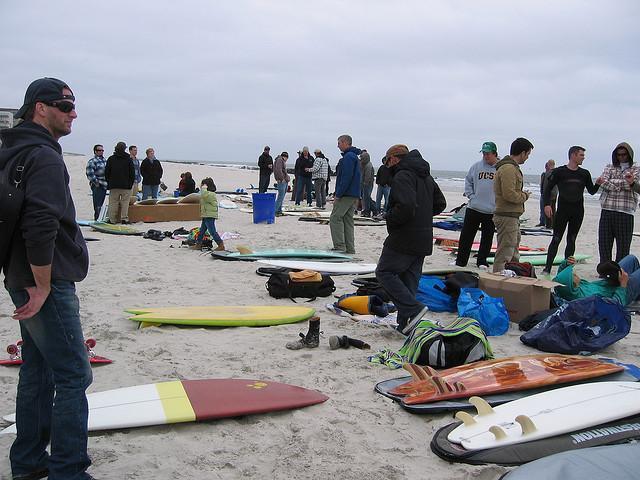How many fins does the white board have?
Give a very brief answer. 4. How many surfboards can be seen?
Give a very brief answer. 6. How many people are there?
Give a very brief answer. 8. 